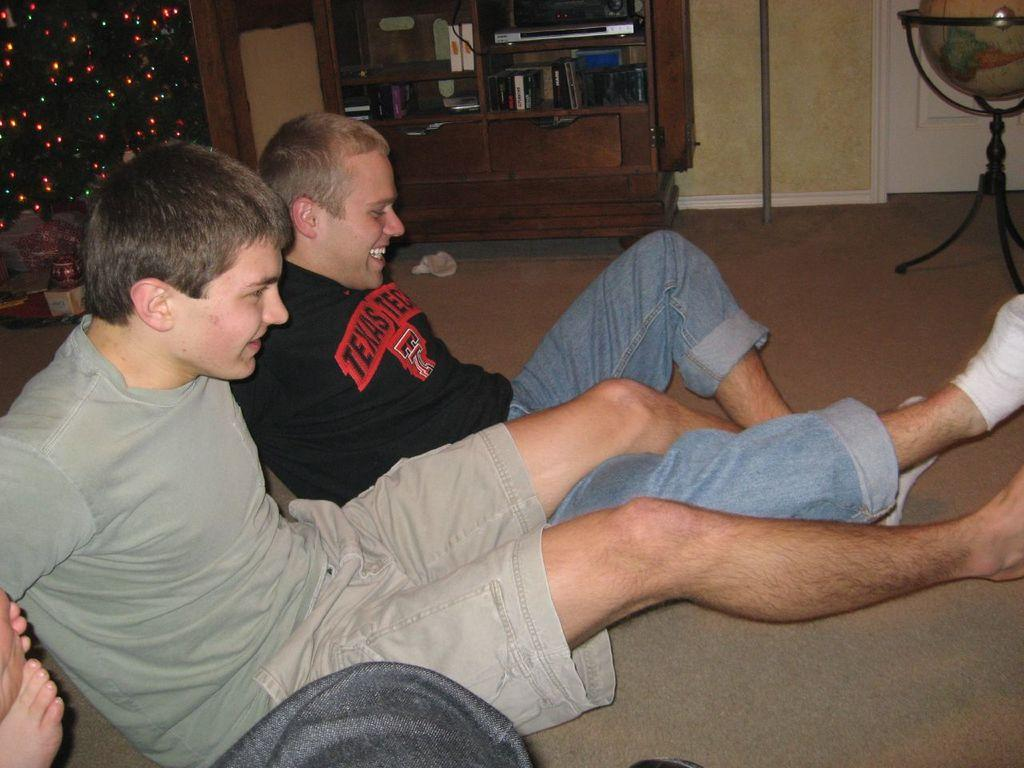<image>
Give a short and clear explanation of the subsequent image. A man with a black sirt and red test that reads, "Texas." wrestles legs with a man next to him. 